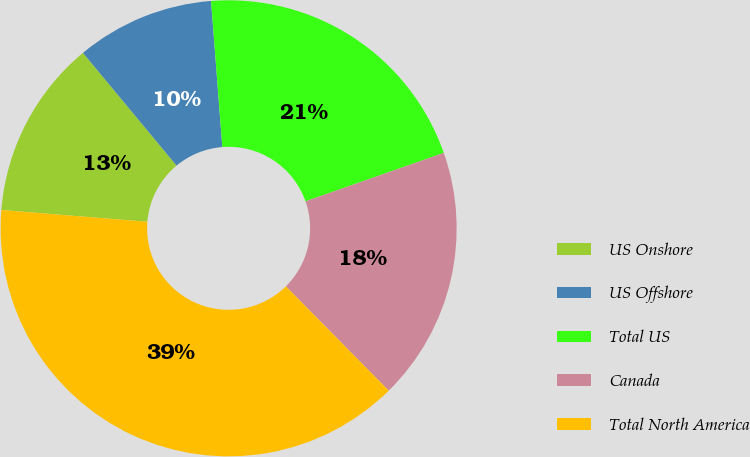<chart> <loc_0><loc_0><loc_500><loc_500><pie_chart><fcel>US Onshore<fcel>US Offshore<fcel>Total US<fcel>Canada<fcel>Total North America<nl><fcel>12.69%<fcel>9.8%<fcel>20.86%<fcel>17.97%<fcel>38.67%<nl></chart> 